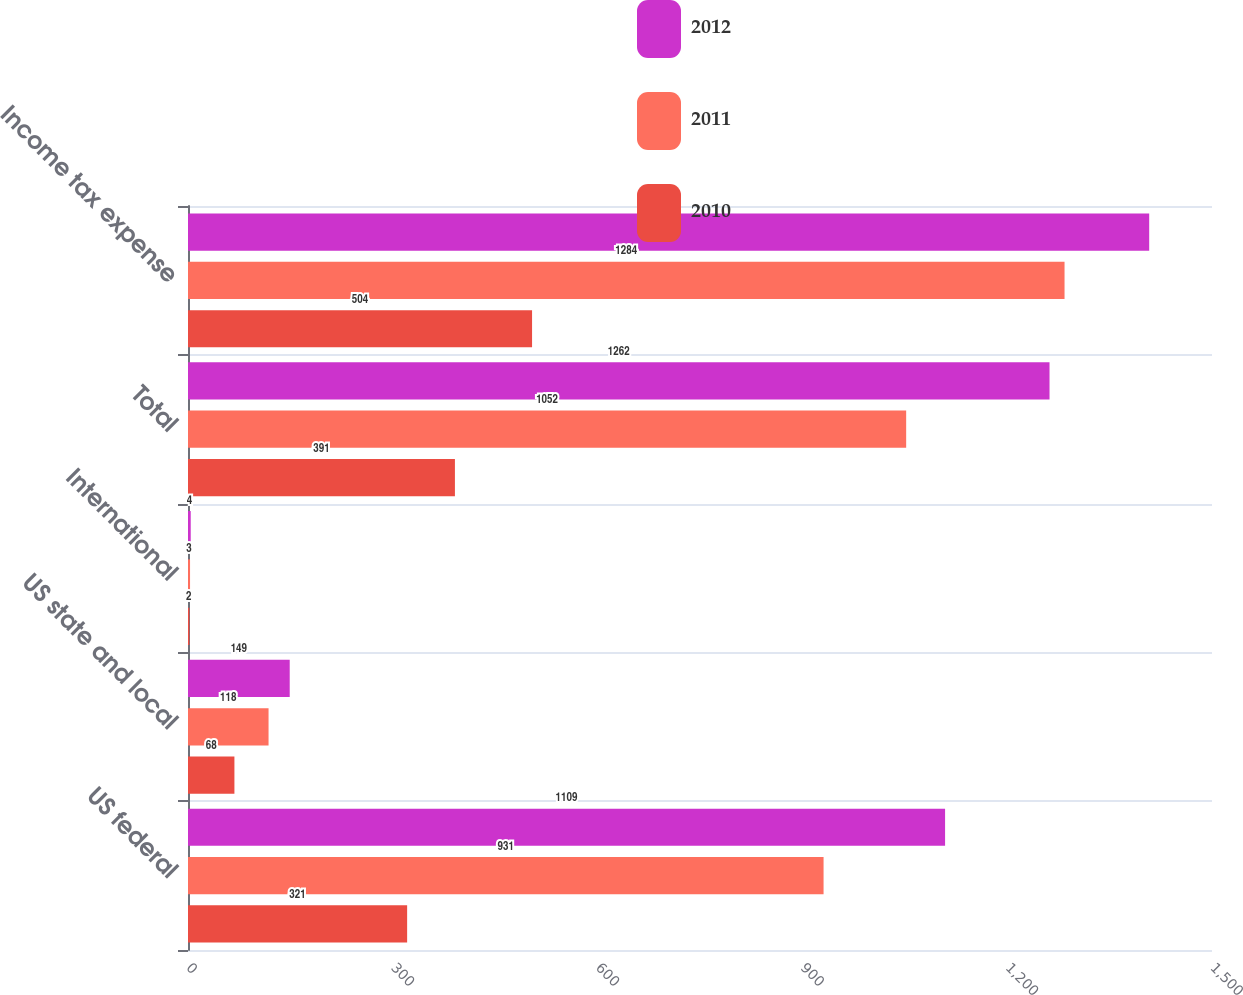<chart> <loc_0><loc_0><loc_500><loc_500><stacked_bar_chart><ecel><fcel>US federal<fcel>US state and local<fcel>International<fcel>Total<fcel>Income tax expense<nl><fcel>2012<fcel>1109<fcel>149<fcel>4<fcel>1262<fcel>1408<nl><fcel>2011<fcel>931<fcel>118<fcel>3<fcel>1052<fcel>1284<nl><fcel>2010<fcel>321<fcel>68<fcel>2<fcel>391<fcel>504<nl></chart> 